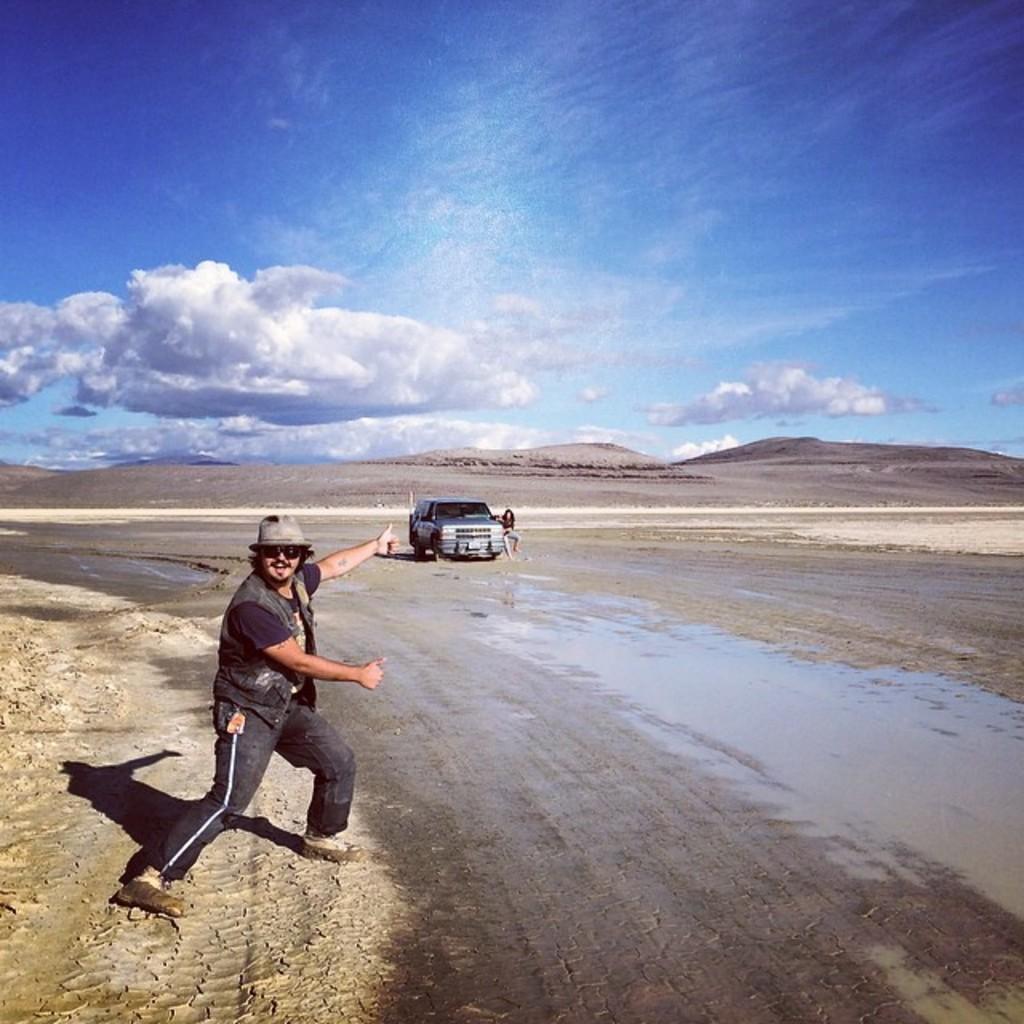Can you describe this image briefly? In this picture I can see a man in front who is standing and I see that he is wearing shades and a cap on his head and I see the path. In the background I see the sky which is a bit cloudy and in the middle of the picture I see a car and a person near to it and I see the water. 